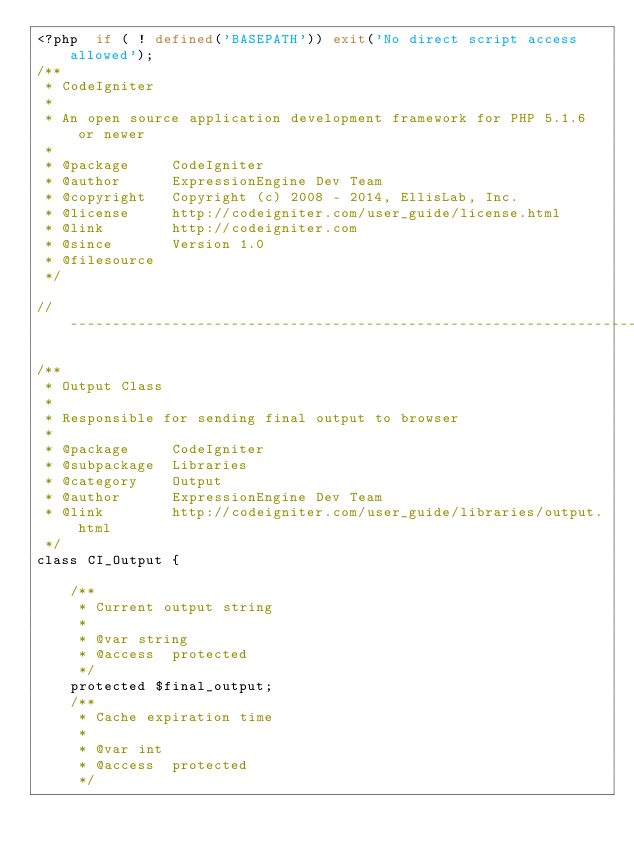Convert code to text. <code><loc_0><loc_0><loc_500><loc_500><_PHP_><?php  if ( ! defined('BASEPATH')) exit('No direct script access allowed');
/**
 * CodeIgniter
 *
 * An open source application development framework for PHP 5.1.6 or newer
 *
 * @package		CodeIgniter
 * @author		ExpressionEngine Dev Team
 * @copyright	Copyright (c) 2008 - 2014, EllisLab, Inc.
 * @license		http://codeigniter.com/user_guide/license.html
 * @link		http://codeigniter.com
 * @since		Version 1.0
 * @filesource
 */

// ------------------------------------------------------------------------

/**
 * Output Class
 *
 * Responsible for sending final output to browser
 *
 * @package		CodeIgniter
 * @subpackage	Libraries
 * @category	Output
 * @author		ExpressionEngine Dev Team
 * @link		http://codeigniter.com/user_guide/libraries/output.html
 */
class CI_Output {

	/**
	 * Current output string
	 *
	 * @var string
	 * @access 	protected
	 */
	protected $final_output;
	/**
	 * Cache expiration time
	 *
	 * @var int
	 * @access 	protected
	 */</code> 